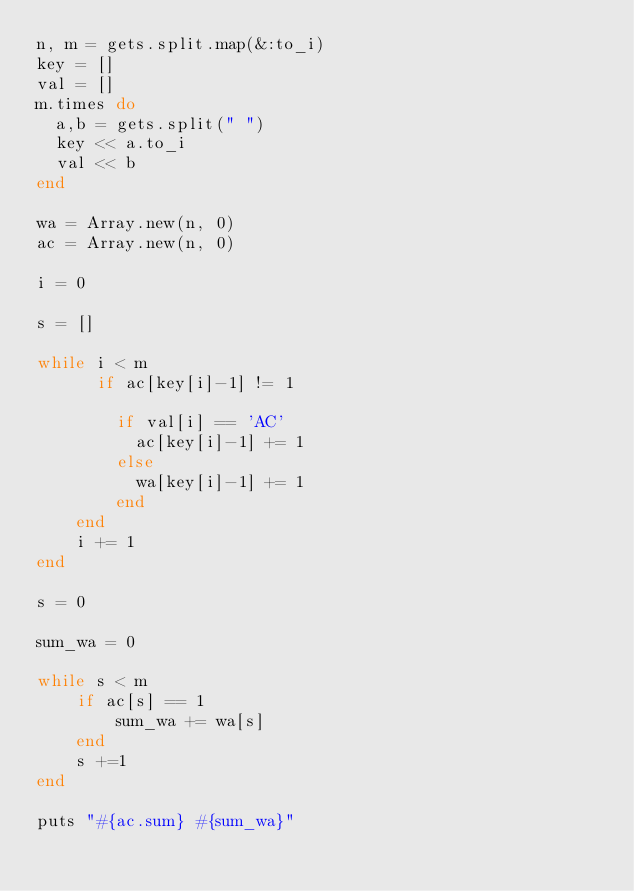Convert code to text. <code><loc_0><loc_0><loc_500><loc_500><_Ruby_>n, m = gets.split.map(&:to_i)
key = []
val = []
m.times do
  a,b = gets.split(" ")
  key << a.to_i
  val << b
end

wa = Array.new(n, 0)
ac = Array.new(n, 0)

i = 0

s = []

while i < m
	  if ac[key[i]-1] != 1

	    if val[i] == 'AC'
		  ac[key[i]-1] += 1
		else
		  wa[key[i]-1] += 1
		end
	end
	i += 1
end

s = 0

sum_wa = 0

while s < m
	if ac[s] == 1
		sum_wa += wa[s]
	end
	s +=1
end

puts "#{ac.sum} #{sum_wa}"</code> 